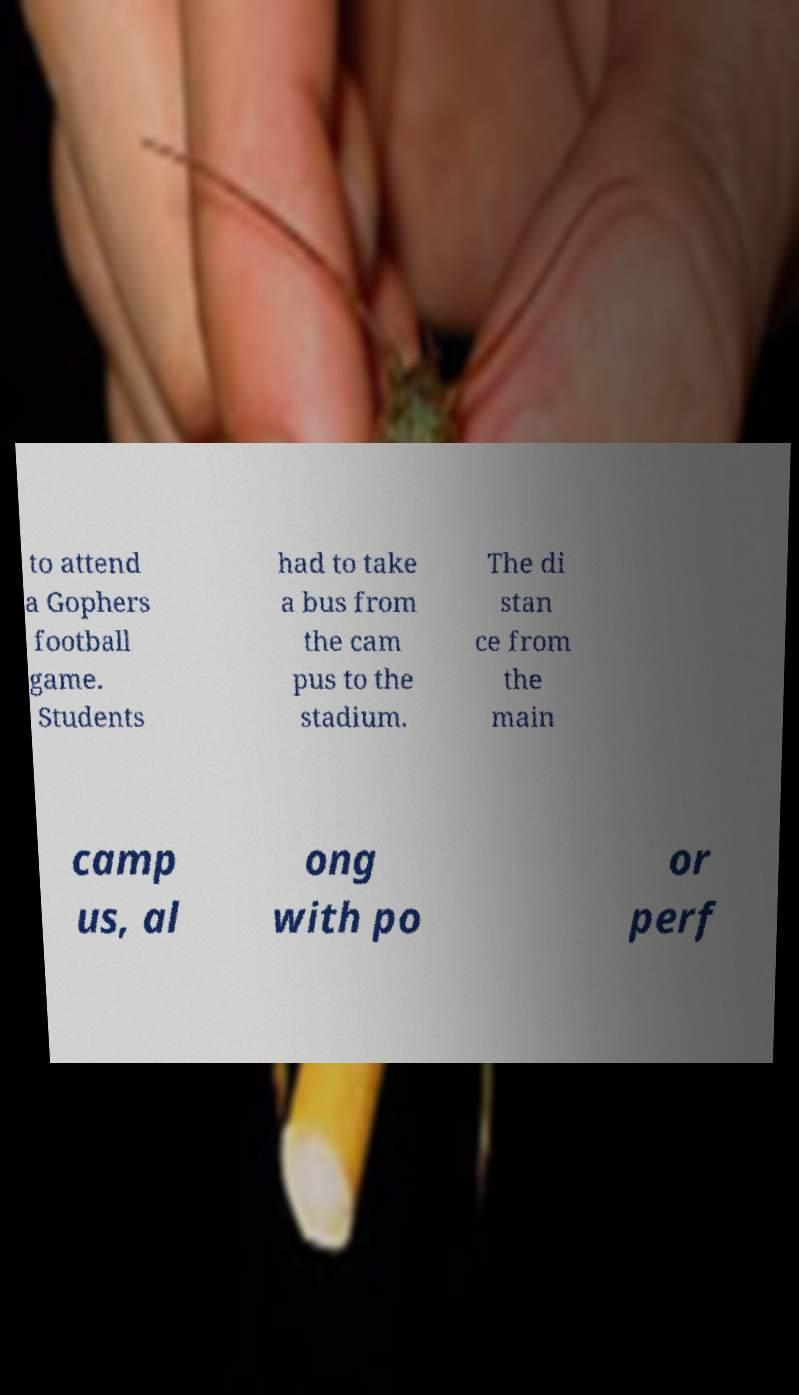What messages or text are displayed in this image? I need them in a readable, typed format. to attend a Gophers football game. Students had to take a bus from the cam pus to the stadium. The di stan ce from the main camp us, al ong with po or perf 